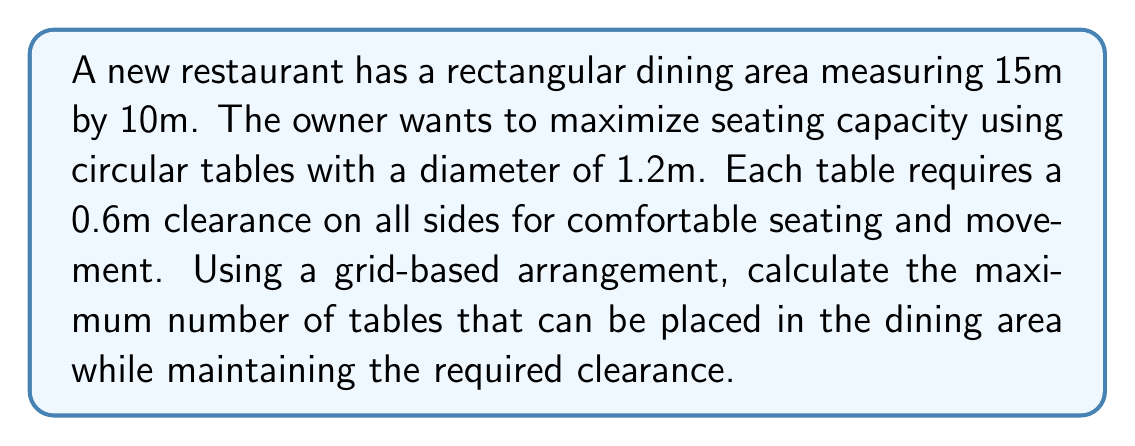Show me your answer to this math problem. To solve this problem, we'll follow these steps:

1. Calculate the effective space needed for each table:
   The total space required for each table is the table diameter plus twice the clearance on each side.
   $$\text{Effective table diameter} = 1.2\text{m} + 2(0.6\text{m}) = 2.4\text{m}$$

2. Determine the number of tables that can fit along the length and width:
   - Length: $15\text{m} \div 2.4\text{m} = 6.25$ (round down to 6)
   - Width: $10\text{m} \div 2.4\text{m} = 4.17$ (round down to 4)

3. Calculate the total number of tables:
   $$\text{Total tables} = 6 \times 4 = 24$$

4. Verify the arrangement:
   - Space used along length: $6 \times 2.4\text{m} = 14.4\text{m}$ (fits within 15m)
   - Space used along width: $4 \times 2.4\text{m} = 9.6\text{m}$ (fits within 10m)

5. Visualize the arrangement:
   [asy]
   size(200);
   for(int i=0; i<6; ++i)
     for(int j=0; j<4; ++j)
       draw(circle((i*2.4,j*2.4),0.6));
   draw(box((0,0),(14.4,9.6)));
   label("15m",(7.2,-0.5));
   label("10m",(-0.5,4.8),W);
   [/asy]

Therefore, the maximum number of tables that can be placed in the dining area while maintaining the required clearance is 24.
Answer: 24 tables 